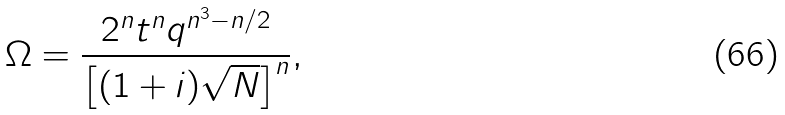<formula> <loc_0><loc_0><loc_500><loc_500>\Omega = \frac { 2 ^ { n } t ^ { n } q ^ { n ^ { 3 } - n / 2 } } { \left [ ( 1 + i ) \sqrt { N } \right ] ^ { n } } ,</formula> 